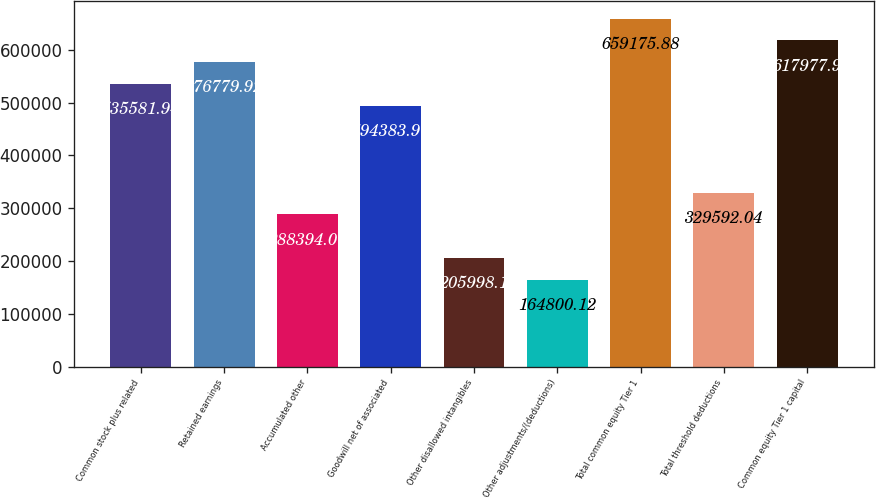Convert chart to OTSL. <chart><loc_0><loc_0><loc_500><loc_500><bar_chart><fcel>Common stock plus related<fcel>Retained earnings<fcel>Accumulated other<fcel>Goodwill net of associated<fcel>Other disallowed intangibles<fcel>Other adjustments/(deductions)<fcel>Total common equity Tier 1<fcel>Total threshold deductions<fcel>Common equity Tier 1 capital<nl><fcel>535582<fcel>576780<fcel>288394<fcel>494384<fcel>205998<fcel>164800<fcel>659176<fcel>329592<fcel>617978<nl></chart> 